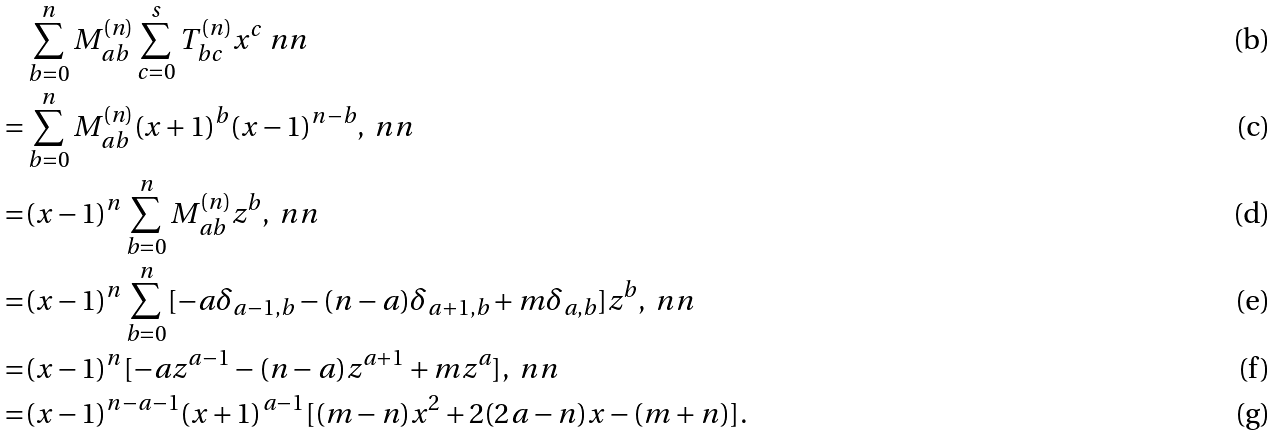<formula> <loc_0><loc_0><loc_500><loc_500>& \sum _ { b = 0 } ^ { n } M ^ { ( n ) } _ { a b } \sum _ { c = 0 } ^ { s } T ^ { ( n ) } _ { b c } x ^ { c } \ n n \\ = & \sum _ { b = 0 } ^ { n } M ^ { ( n ) } _ { a b } ( x + 1 ) ^ { b } ( x - 1 ) ^ { n - b } , \ n n \\ = & ( x - 1 ) ^ { n } \sum _ { b = 0 } ^ { n } M ^ { ( n ) } _ { a b } z ^ { b } , \ n n \\ = & ( x - 1 ) ^ { n } \sum _ { b = 0 } ^ { n } [ - a \delta _ { a - 1 , b } - ( n - a ) \delta _ { a + 1 , b } + m \delta _ { a , b } ] z ^ { b } , \ n n \\ = & ( x - 1 ) ^ { n } [ - a z ^ { a - 1 } - ( n - a ) z ^ { a + 1 } + m z ^ { a } ] , \ n n \\ = & ( x - 1 ) ^ { n - a - 1 } ( x + 1 ) ^ { a - 1 } [ ( m - n ) x ^ { 2 } + 2 ( 2 a - n ) x - ( m + n ) ] .</formula> 